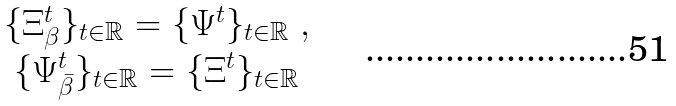Convert formula to latex. <formula><loc_0><loc_0><loc_500><loc_500>\begin{array} { c } \{ \Xi ^ { t } _ { \beta } \} _ { t \in \mathbb { R } } = \{ \Psi ^ { t } \} _ { t \in \mathbb { R } } \ , \\ \{ \Psi ^ { t } _ { \bar { \beta } } \} _ { t \in \mathbb { R } } = \{ \Xi ^ { t } \} _ { t \in \mathbb { R } } \end{array}</formula> 